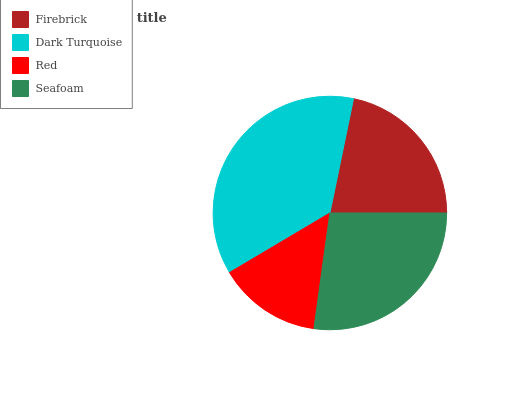Is Red the minimum?
Answer yes or no. Yes. Is Dark Turquoise the maximum?
Answer yes or no. Yes. Is Dark Turquoise the minimum?
Answer yes or no. No. Is Red the maximum?
Answer yes or no. No. Is Dark Turquoise greater than Red?
Answer yes or no. Yes. Is Red less than Dark Turquoise?
Answer yes or no. Yes. Is Red greater than Dark Turquoise?
Answer yes or no. No. Is Dark Turquoise less than Red?
Answer yes or no. No. Is Seafoam the high median?
Answer yes or no. Yes. Is Firebrick the low median?
Answer yes or no. Yes. Is Firebrick the high median?
Answer yes or no. No. Is Dark Turquoise the low median?
Answer yes or no. No. 